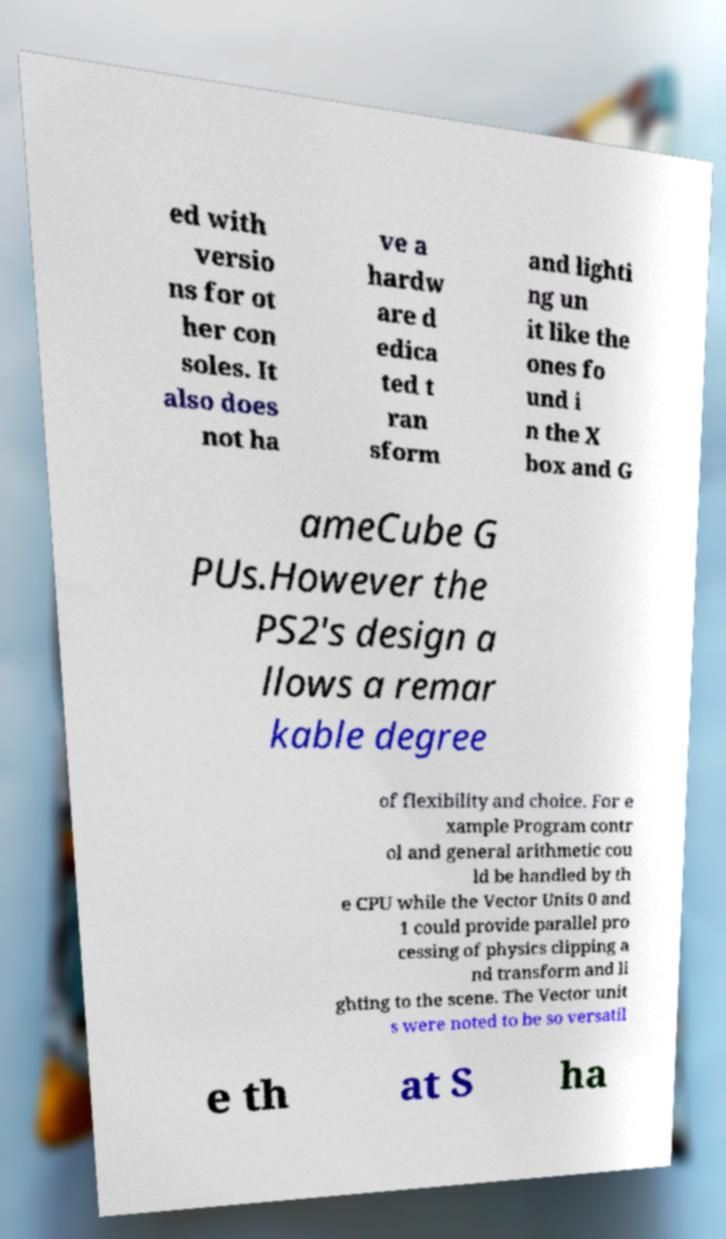For documentation purposes, I need the text within this image transcribed. Could you provide that? ed with versio ns for ot her con soles. It also does not ha ve a hardw are d edica ted t ran sform and lighti ng un it like the ones fo und i n the X box and G ameCube G PUs.However the PS2's design a llows a remar kable degree of flexibility and choice. For e xample Program contr ol and general arithmetic cou ld be handled by th e CPU while the Vector Units 0 and 1 could provide parallel pro cessing of physics clipping a nd transform and li ghting to the scene. The Vector unit s were noted to be so versatil e th at S ha 